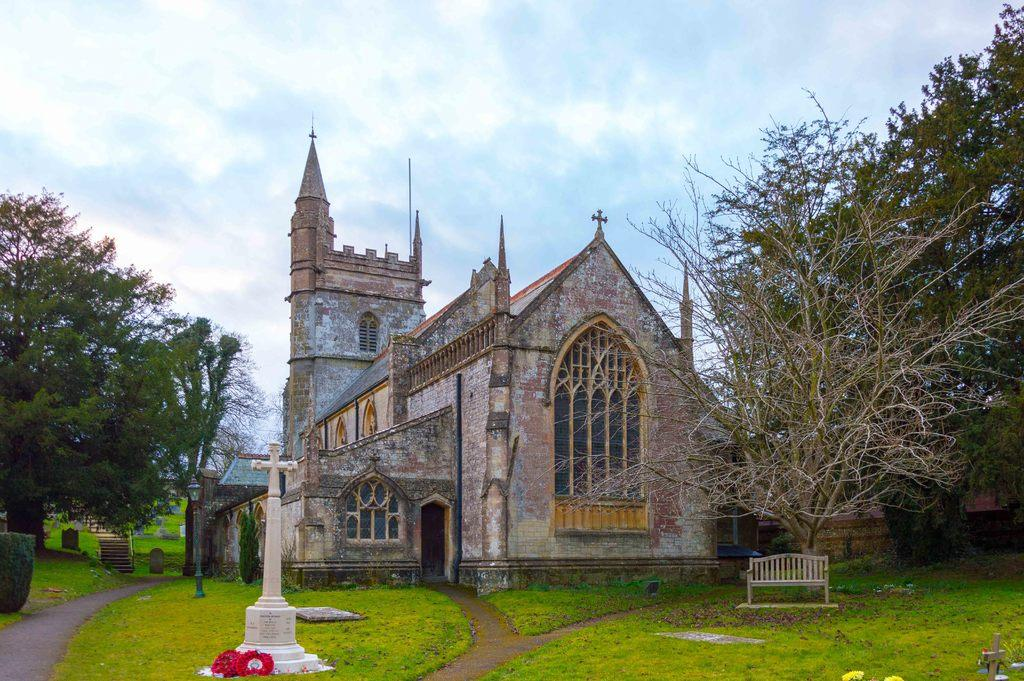What type of structure is present in the image? There is a building in the image. What celestial objects can be seen in the image? Stars are visible in the image. What type of plants are present in the image? There are flowers, grass, and trees in the image. What type of seating is available in the image? There is a bench in the image. What part of the natural environment is visible in the image? The sky is visible in the background of the image. What type of corn is being served in the stew on the scale in the image? There is no corn, stew, or scale present in the image. 